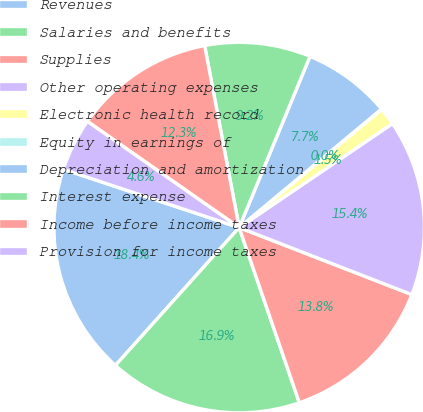Convert chart to OTSL. <chart><loc_0><loc_0><loc_500><loc_500><pie_chart><fcel>Revenues<fcel>Salaries and benefits<fcel>Supplies<fcel>Other operating expenses<fcel>Electronic health record<fcel>Equity in earnings of<fcel>Depreciation and amortization<fcel>Interest expense<fcel>Income before income taxes<fcel>Provision for income taxes<nl><fcel>18.45%<fcel>16.91%<fcel>13.84%<fcel>15.38%<fcel>1.55%<fcel>0.02%<fcel>7.7%<fcel>9.23%<fcel>12.3%<fcel>4.62%<nl></chart> 